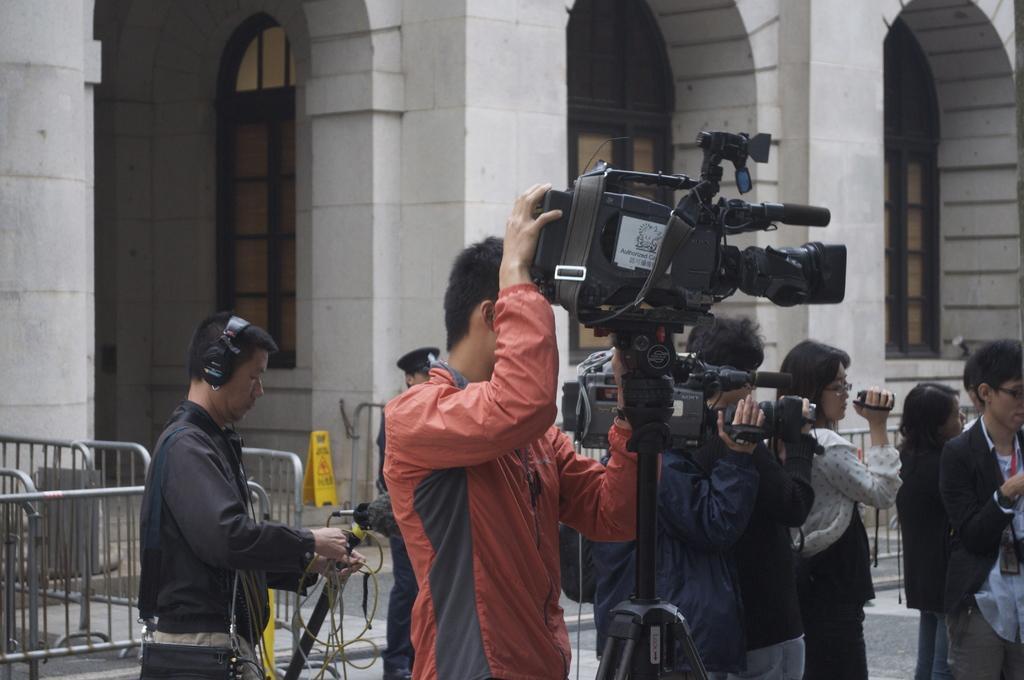Can you describe this image briefly? In this picture we can see some people are holding cameras with their hands, standing on the floor, fences, some objects and in the background we can see a building with windows. 